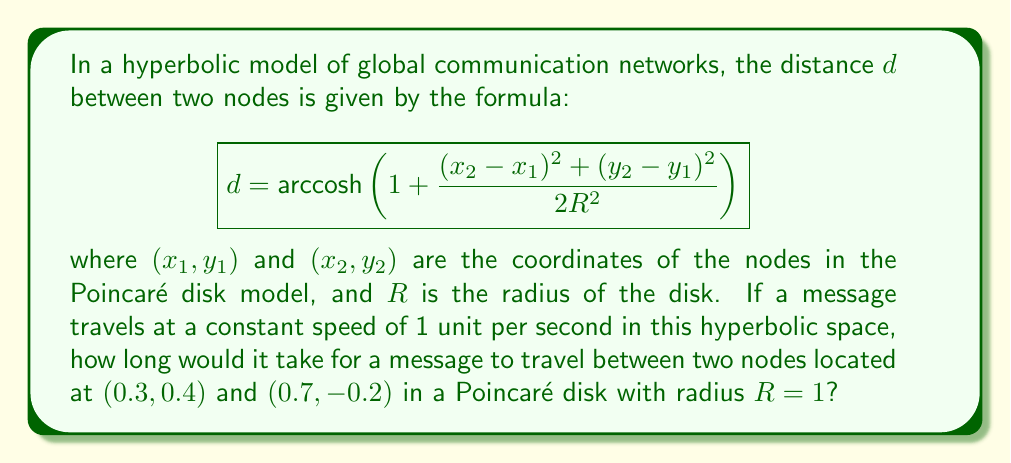Show me your answer to this math problem. To solve this problem, we'll follow these steps:

1) First, let's identify the given values:
   $(x_1, y_1) = (0.3, 0.4)$
   $(x_2, y_2) = (0.7, -0.2)$
   $R = 1$

2) Now, let's calculate the differences:
   $(x_2 - x_1) = 0.7 - 0.3 = 0.4$
   $(y_2 - y_1) = -0.2 - 0.4 = -0.6$

3) Square these differences:
   $(x_2 - x_1)^2 = 0.4^2 = 0.16$
   $(y_2 - y_1)^2 = (-0.6)^2 = 0.36$

4) Sum the squared differences:
   $(x_2 - x_1)^2 + (y_2 - y_1)^2 = 0.16 + 0.36 = 0.52$

5) Now, let's plug this into our distance formula:

   $$d = \text{arccosh}\left(1 + \frac{0.52}{2(1)^2}\right)$$

6) Simplify:
   $$d = \text{arccosh}(1.26)$$

7) Calculate the arccosh:
   $$d \approx 0.7234$$

8) Since the message travels at 1 unit per second, the time taken is equal to the distance. Therefore, the message would take approximately 0.7234 seconds to travel between the two nodes.

This hyperbolic model reflects how information can travel faster in a globally connected network than in a flat Euclidean space, mirroring the experience of an immigrant adapting to new, more efficient ways of communication in a foreign land.
Answer: 0.7234 seconds 